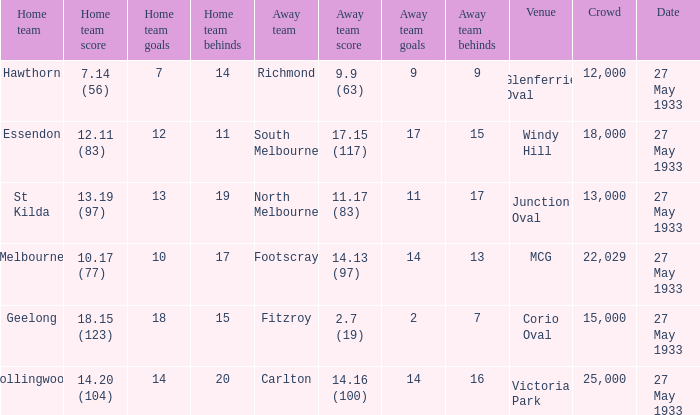In the match where the home team scored 14.20 (104), how many attendees were in the crowd? 25000.0. 